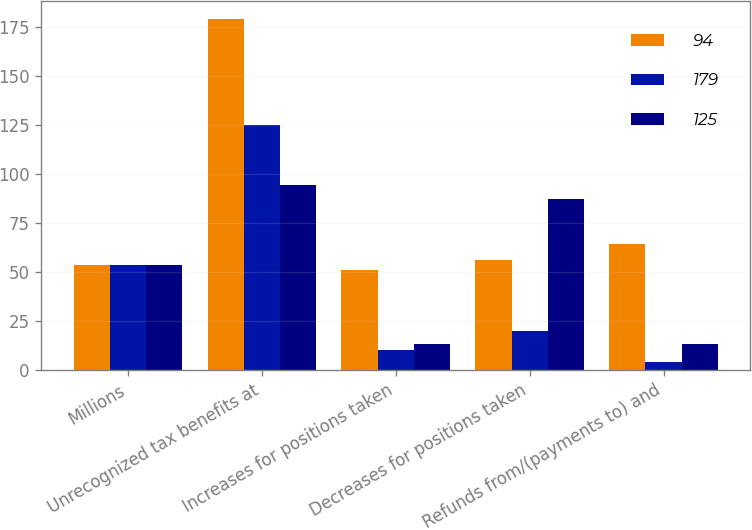Convert chart to OTSL. <chart><loc_0><loc_0><loc_500><loc_500><stacked_bar_chart><ecel><fcel>Millions<fcel>Unrecognized tax benefits at<fcel>Increases for positions taken<fcel>Decreases for positions taken<fcel>Refunds from/(payments to) and<nl><fcel>94<fcel>53.5<fcel>179<fcel>51<fcel>56<fcel>64<nl><fcel>179<fcel>53.5<fcel>125<fcel>10<fcel>20<fcel>4<nl><fcel>125<fcel>53.5<fcel>94<fcel>13<fcel>87<fcel>13<nl></chart> 